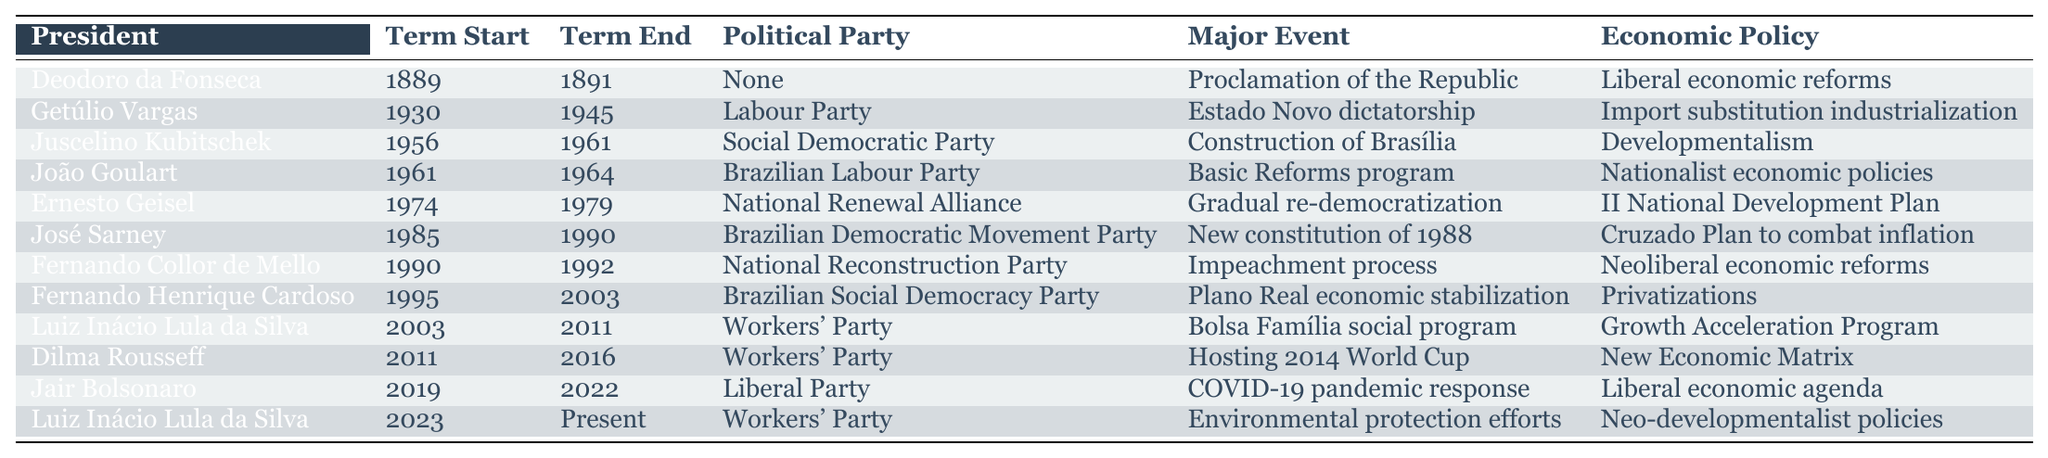What year did Getúlio Vargas start his term? In the data table, under the "Term Start" column for Getúlio Vargas, the year is listed as 1930.
Answer: 1930 What major event is associated with Fernando Collor de Mello's presidency? In the table, under the "Major Event" column for Fernando Collor de Mello, it states "Impeachment process."
Answer: Impeachment process Which president served during the construction of Brasília? According to the "Major Event" column of the table, Juscelino Kubitschek is associated with the "Construction of Brasília" during his term from 1956 to 1961.
Answer: Juscelino Kubitschek How many presidents served between 1985 and 2003? To answer this, we count the presidents in the table with terms starting from 1985 to 2003, which are José Sarney (1985-1990), Fernando Collor de Mello (1990-1992), and Fernando Henrique Cardoso (1995-2003). This gives us a total of three presidents.
Answer: 3 What political party did João Goulart belong to? In the table, the "Political Party" column for João Goulart shows "Brazilian Labour Party."
Answer: Brazilian Labour Party Which economic policy was implemented by José Sarney? Referring to the table, under "Economic Policy" column for José Sarney, it is noted as "Cruzado Plan to combat inflation."
Answer: Cruzado Plan to combat inflation What is the duration of Getúlio Vargas's presidency in years? Getúlio Vargas's term began in 1930 and ended in 1945. To calculate the duration: 1945 - 1930 = 15 years. Therefore, he served for 15 years.
Answer: 15 years Which president had the longest term in office? To determine this, we check the term lengths: Deodoro da Fonseca (2 years), Getúlio Vargas (15 years), Juscelino Kubitschek (5 years), João Goulart (3 years), Ernesto Geisel (5 years), José Sarney (5 years), Fernando Collor de Mello (2 years), Fernando Henrique Cardoso (8 years), Luiz Inácio Lula da Silva (8 years), Dilma Rousseff (5 years), Jair Bolsonaro (3 years), and Luiz Inácio Lula da Silva (currently in office). The longest term is that of Getúlio Vargas with 15 years.
Answer: Getúlio Vargas Is it true that Jair Bolsonaro’s presidency lasted the same time as Fernando Collor de Mello’s? By examining their terms, Jair Bolsonaro served from 2019 to 2022 (3 years), while Fernando Collor de Mello served from 1990 to 1992 (2 years). Since 3 years is not the same as 2 years, the statement is false.
Answer: No Which two presidents belonged to the Workers' Party? In the table, we identify Luiz Inácio Lula da Silva and Dilma Rousseff as the two presidents listed under the "Workers' Party."
Answer: Luiz Inácio Lula da Silva and Dilma Rousseff What are the major events during Luiz Inácio Lula da Silva's second term? To find this, we check the "Major Event" column for Luiz Inácio Lula da Silva's second term (2023-present), which mentions "Environmental protection efforts."
Answer: Environmental protection efforts 